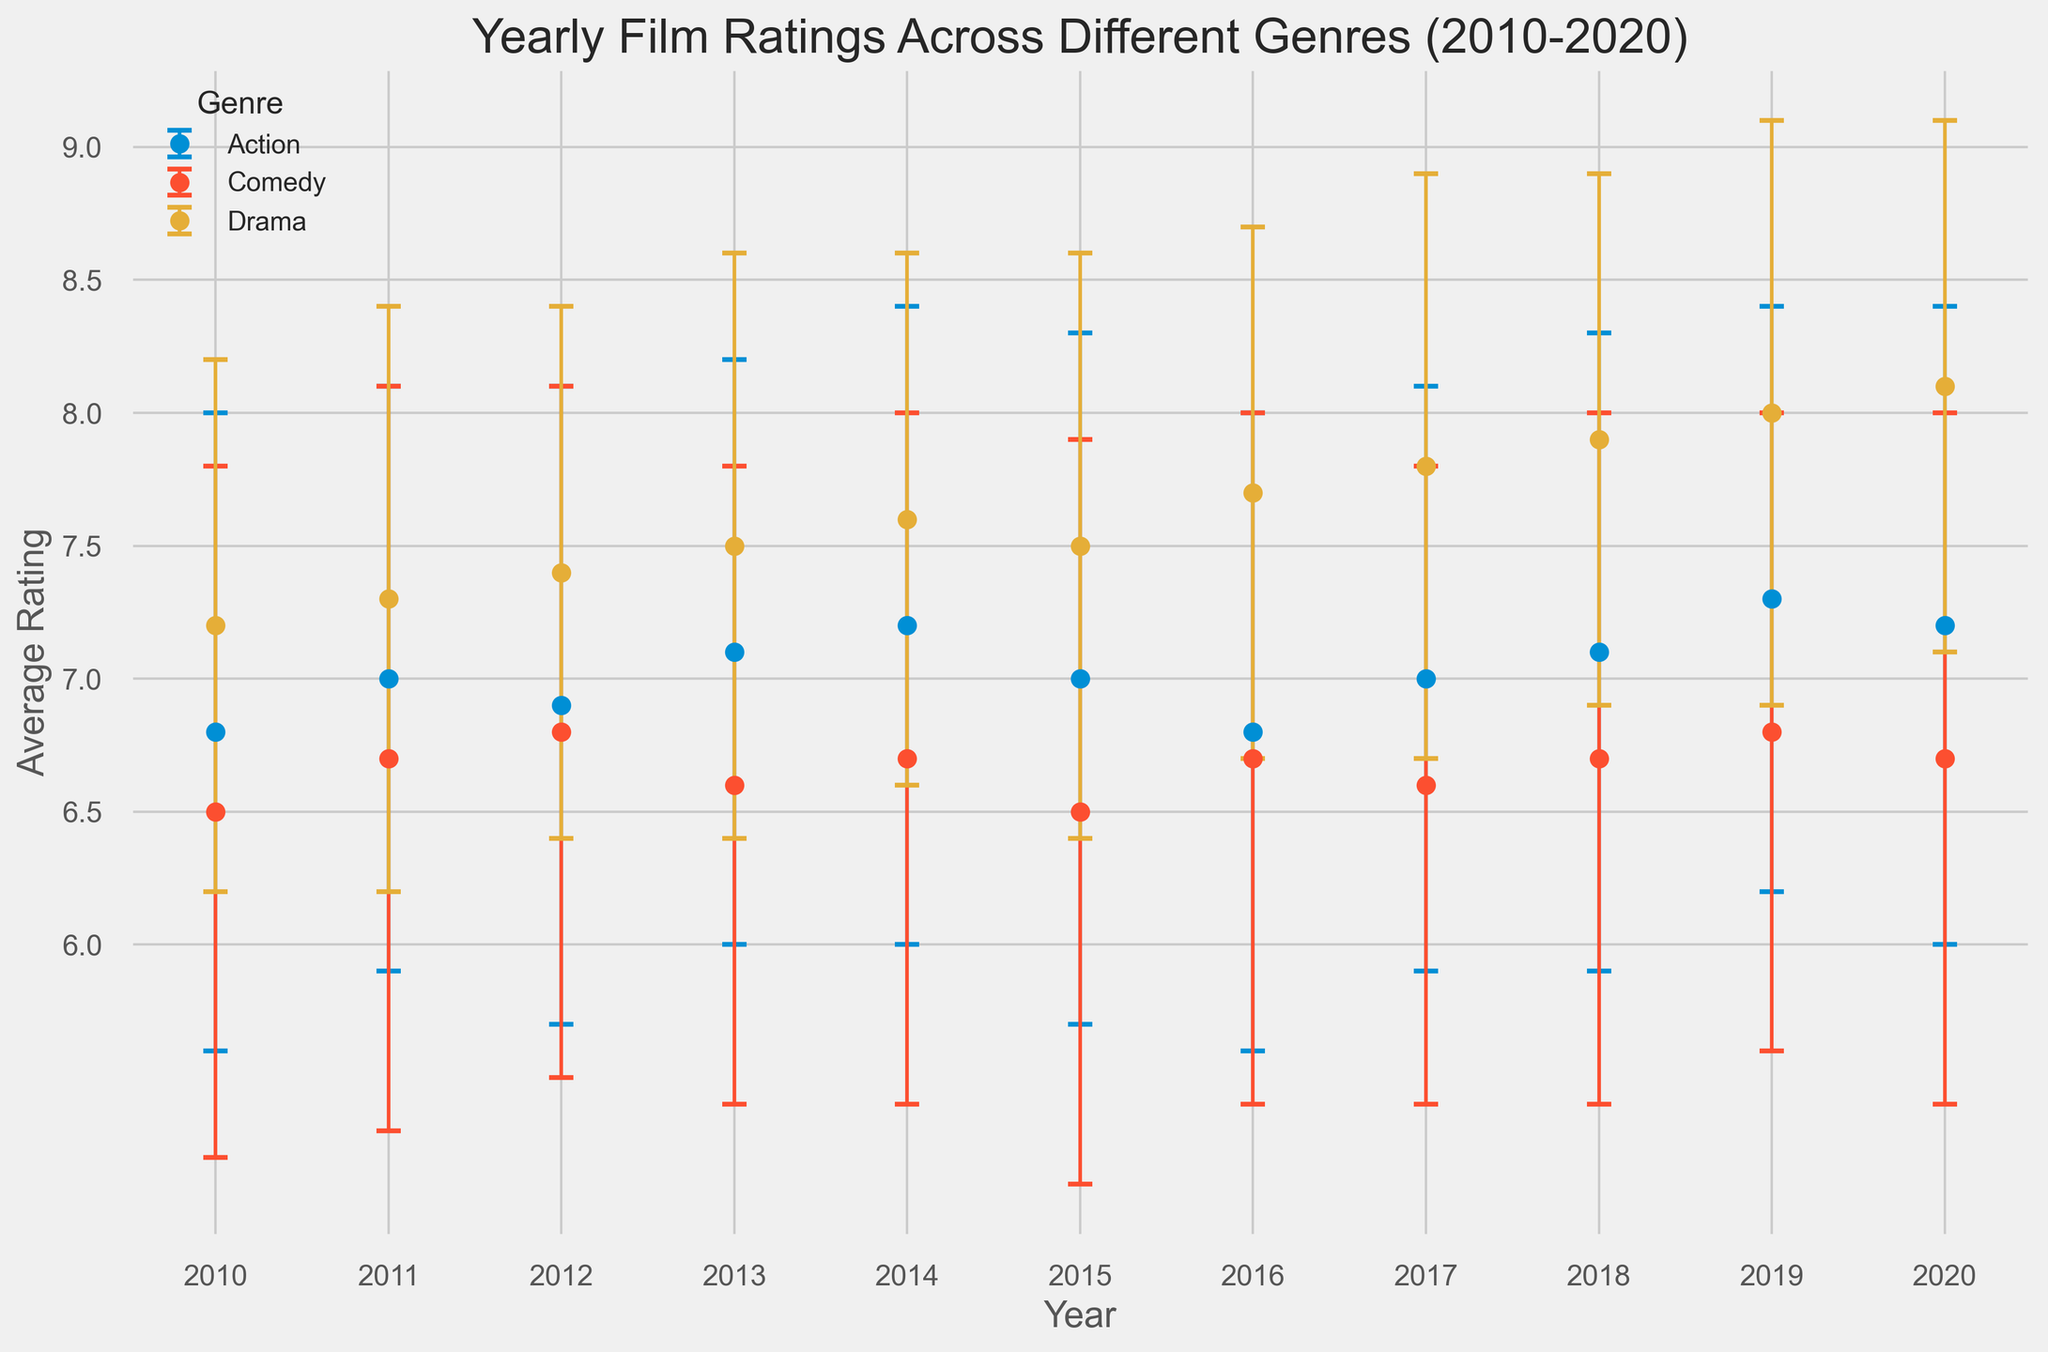what genre has the highest average rating in 2020? Look at the data points for 2020 and find the genre with the highest point on the y-axis. The highest point corresponds to the genre with the highest average rating.
Answer: Drama how much higher was the average rating for drama in 2019 compared to comedy in the same year? Find the data points for drama and comedy in 2019. Subtract the average rating of comedy from the average rating of drama.
Answer: 1.2 between 2014 and 2016, which genre shows the least variation in average ratings? Look at the error bars for each genre between 2014 and 2016. The genre with the least variation will have error bars of a similar size, indicating smaller changes.
Answer: Drama what is the average of the average ratings for action movies from 2010 to 2020 excluding 2011? Add the average ratings of action movies from 2010, 2012, 2013, 2014, 2015, 2016, 2017, 2018, 2019, and 2020, then divide by the number of years (10). (6.8 + 6.9 + 7.1 + 7.2 + 7 + 6.8 + 7 + 7.1 + 7.3 + 7.2) / 10 = 70.4 / 10
Answer: 7.04 in which year was the average rating for comedy lower than for both action and drama? Compare the average ratings of the three genres for each year, and find the year(s) where comedy has the lowest rating among them.
Answer: 2010 how did the average rating for action movies change from 2012 to 2013? Find the average ratings for action movies in 2012 and 2013. Subtract the 2012 rating from the 2013 rating to determine the change. (7.1 - 6.9)
Answer: 0.2 which genre shows the most consistent improvement in average ratings from 2010 to 2020? Look at the trend lines for each genre from 2010 to 2020. The genre with the most upward slope indicates consistent improvement.
Answer: Drama by how much did the average rating for comedy movies change from 2010 to 2020? Find the average ratings for comedy in 2010 and 2020. Subtract the 2010 rating from the 2020 rating to see the change. (6.7 - 6.5)
Answer: 0.2 if you were to choose a year when action movies received the second highest average rating, which year would that be? Compare the average ratings of action movies for each year. Identify the year with the highest rating, then find the year with the second highest rating.
Answer: 2014 how much higher is the confidence interval for drama movies in 2020 compared to action movies in 2020? Find the error bar lengths for drama and action in 2020 and compare them. Calculate the difference. The error bar for drama is 1.0 and for action is 1.2, so (1.2 - 1.0).
Answer: 0.2 